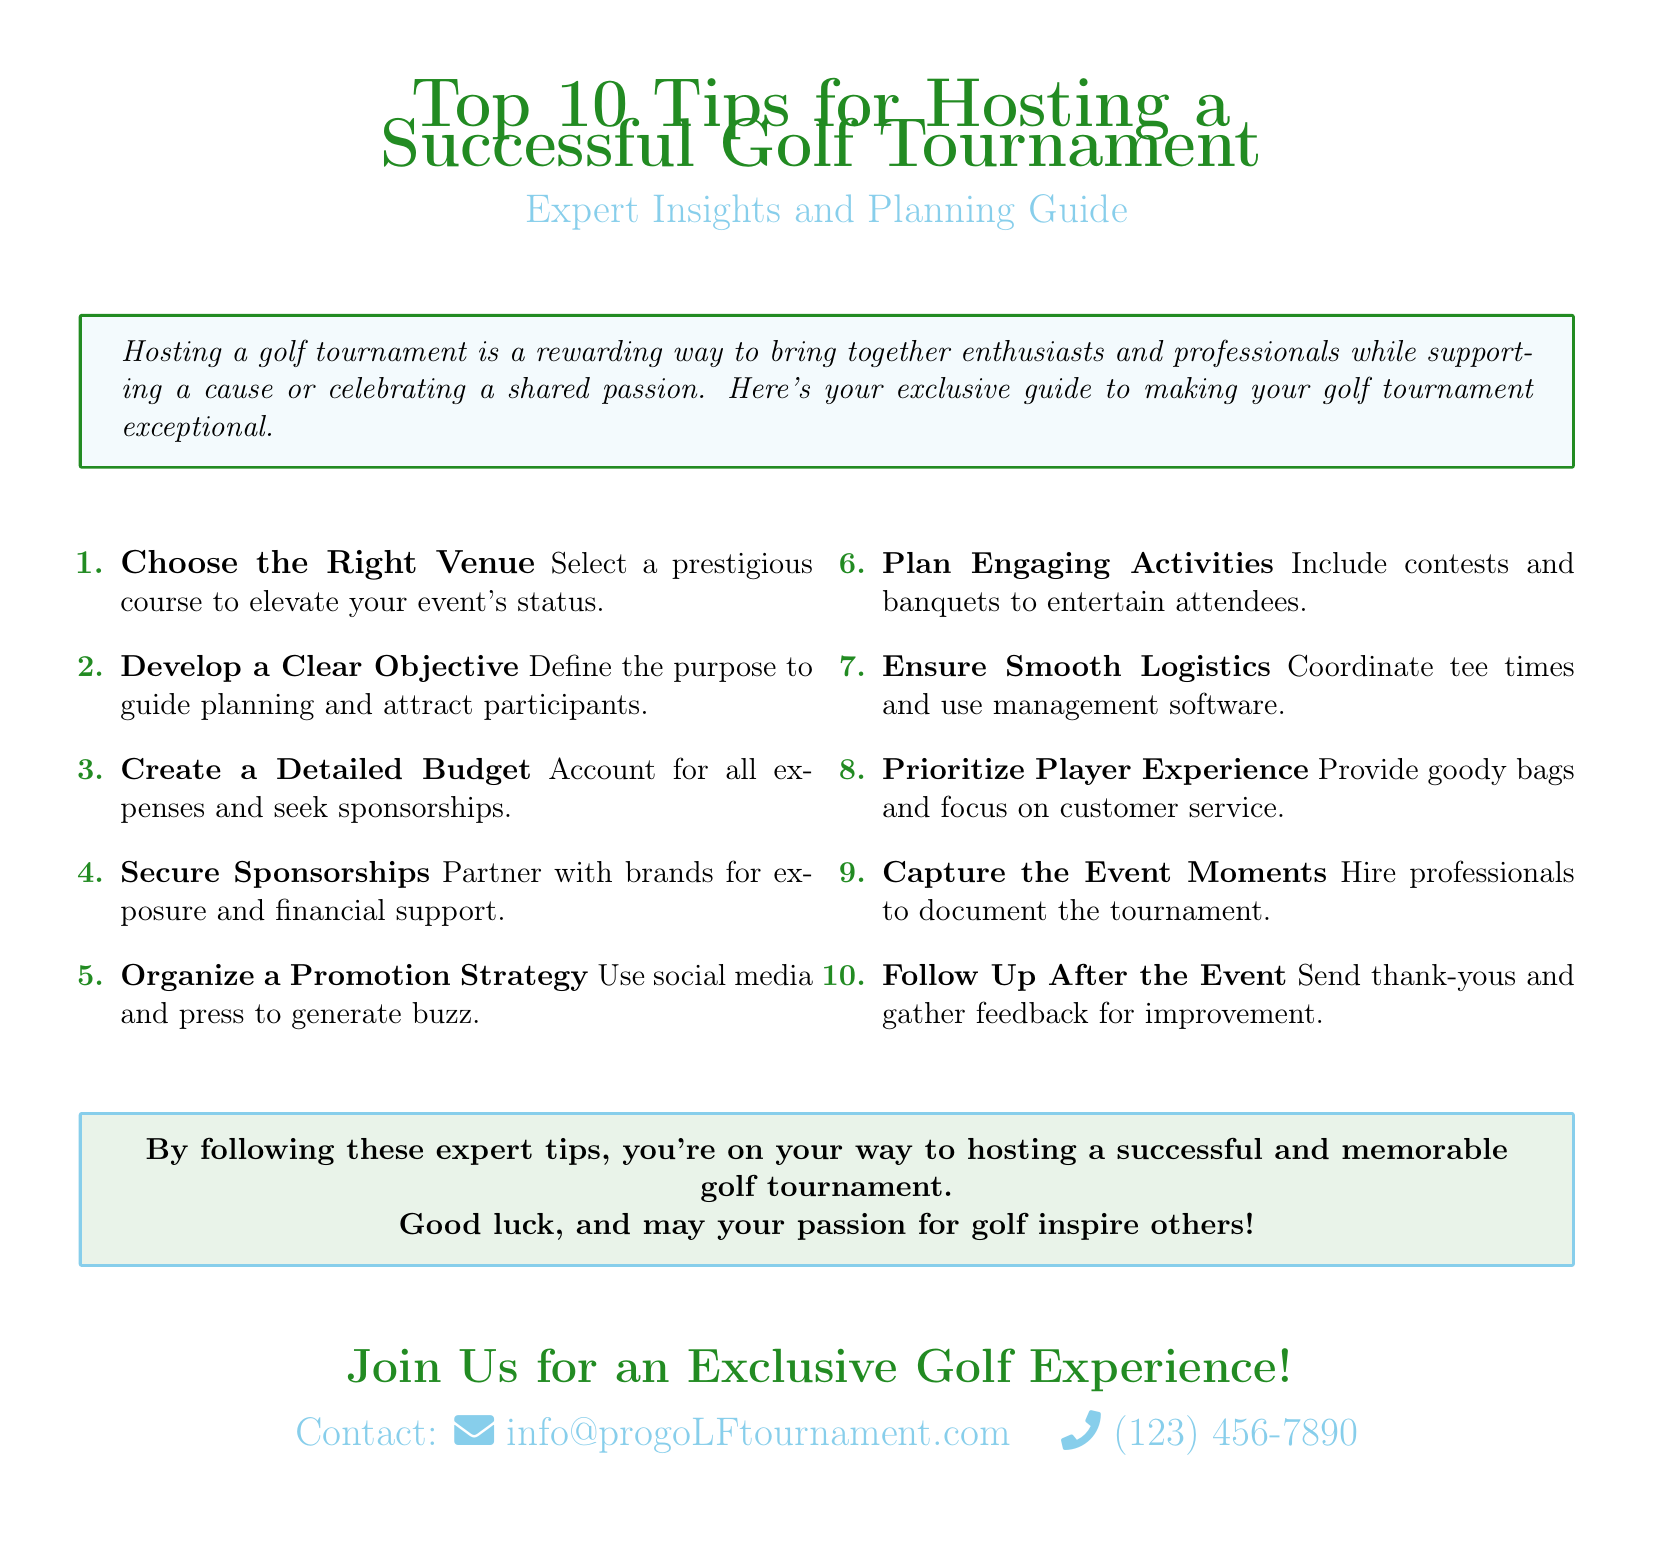What is the first tip for hosting a golf tournament? The first tip listed in the document is to "Choose the Right Venue".
Answer: Choose the Right Venue What should you define to guide planning? The document suggests that you should "Develop a Clear Objective" to guide planning.
Answer: Develop a Clear Objective How many tips are listed in the document? The total number of tips provided in the document is ten.
Answer: 10 What is advised to include for player experience? The document recommends to "Provide goody bags" to enhance player experience.
Answer: Provide goody bags What should you send after the event? The document states you should "Send thank-yous" after the event.
Answer: Send thank-yous What is a useful strategy for generating interest in the tournament? According to the tips, you should "Organize a Promotion Strategy" to generate interest.
Answer: Organize a Promotion Strategy What type of activities should be planned for attendees? The document suggests to "Plan Engaging Activities" for attendees.
Answer: Plan Engaging Activities What color theme is used for the flyer? The color theme used in the flyer includes grass green and sky blue.
Answer: grass green and sky blue What type of professionals should document the tournament? The document advises to "Hire professionals" to document the tournament.
Answer: Hire professionals 